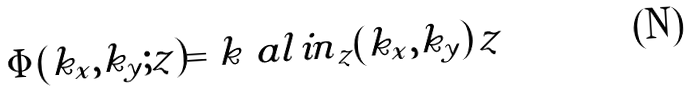Convert formula to latex. <formula><loc_0><loc_0><loc_500><loc_500>\Phi ( k _ { x } , k _ { y } ; z ) = k \ a l { i n } _ { z } ( k _ { x } , k _ { y } ) \, z</formula> 